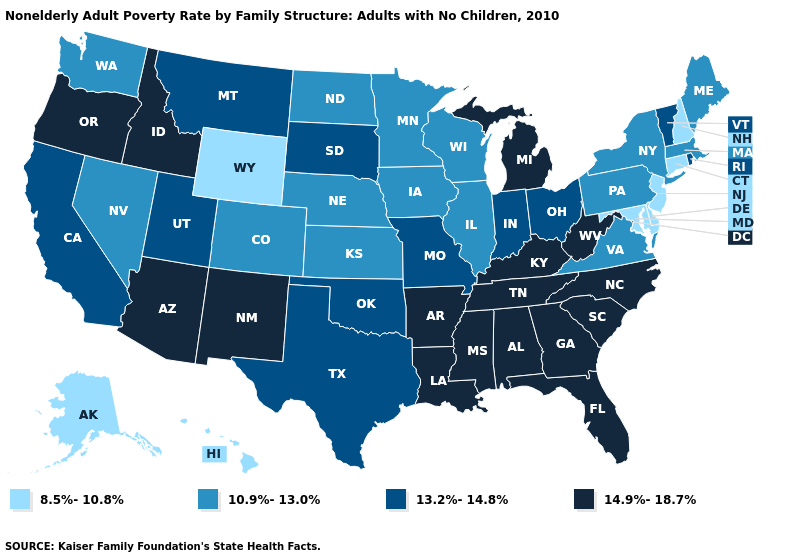What is the value of North Dakota?
Concise answer only. 10.9%-13.0%. Name the states that have a value in the range 14.9%-18.7%?
Concise answer only. Alabama, Arizona, Arkansas, Florida, Georgia, Idaho, Kentucky, Louisiana, Michigan, Mississippi, New Mexico, North Carolina, Oregon, South Carolina, Tennessee, West Virginia. Does Idaho have the lowest value in the USA?
Quick response, please. No. What is the value of Florida?
Short answer required. 14.9%-18.7%. Name the states that have a value in the range 13.2%-14.8%?
Give a very brief answer. California, Indiana, Missouri, Montana, Ohio, Oklahoma, Rhode Island, South Dakota, Texas, Utah, Vermont. Name the states that have a value in the range 14.9%-18.7%?
Quick response, please. Alabama, Arizona, Arkansas, Florida, Georgia, Idaho, Kentucky, Louisiana, Michigan, Mississippi, New Mexico, North Carolina, Oregon, South Carolina, Tennessee, West Virginia. What is the value of Michigan?
Concise answer only. 14.9%-18.7%. Name the states that have a value in the range 13.2%-14.8%?
Give a very brief answer. California, Indiana, Missouri, Montana, Ohio, Oklahoma, Rhode Island, South Dakota, Texas, Utah, Vermont. Among the states that border Washington , which have the lowest value?
Write a very short answer. Idaho, Oregon. Which states hav the highest value in the Northeast?
Keep it brief. Rhode Island, Vermont. What is the value of Arizona?
Write a very short answer. 14.9%-18.7%. Among the states that border West Virginia , which have the highest value?
Give a very brief answer. Kentucky. Does New Hampshire have a lower value than Alaska?
Short answer required. No. Among the states that border New Mexico , which have the highest value?
Answer briefly. Arizona. What is the lowest value in states that border Pennsylvania?
Short answer required. 8.5%-10.8%. 